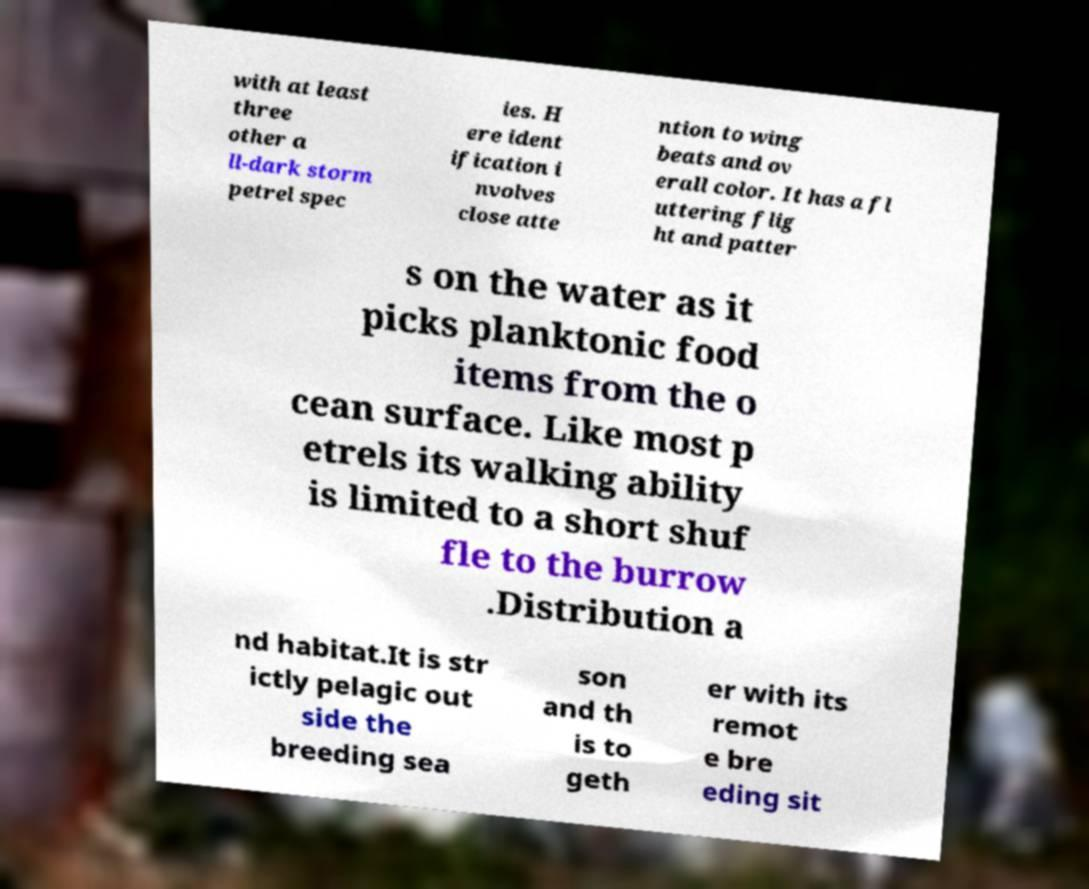Could you assist in decoding the text presented in this image and type it out clearly? with at least three other a ll-dark storm petrel spec ies. H ere ident ification i nvolves close atte ntion to wing beats and ov erall color. It has a fl uttering flig ht and patter s on the water as it picks planktonic food items from the o cean surface. Like most p etrels its walking ability is limited to a short shuf fle to the burrow .Distribution a nd habitat.It is str ictly pelagic out side the breeding sea son and th is to geth er with its remot e bre eding sit 